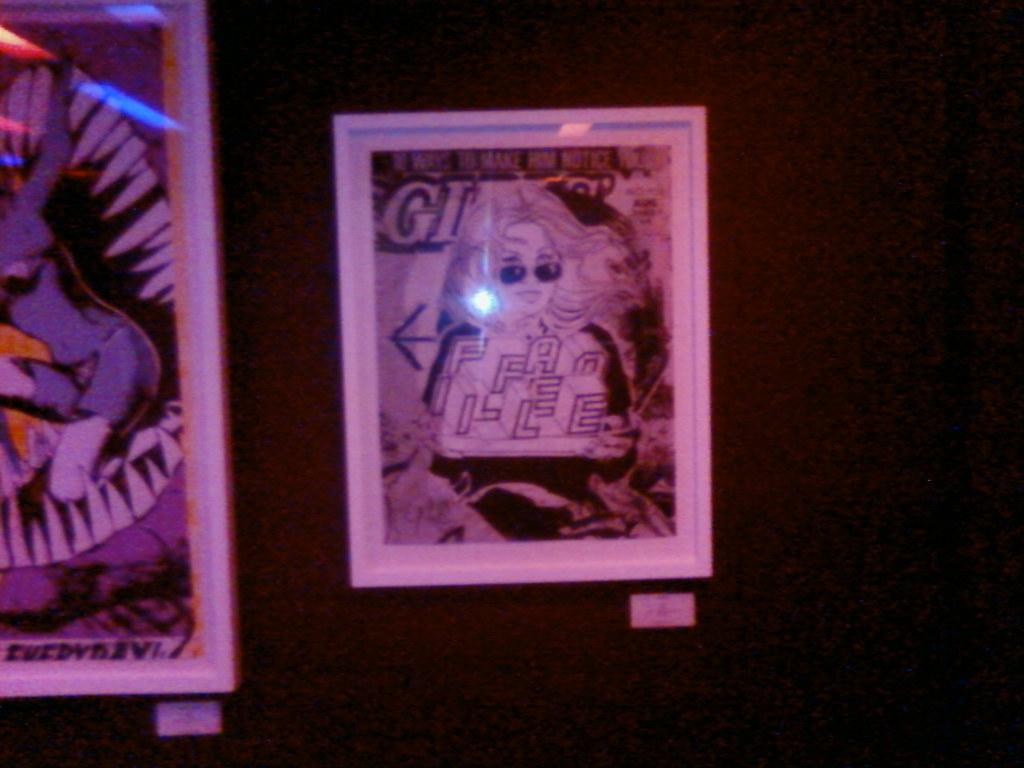<image>
Render a clear and concise summary of the photo. a framed paper that says 'gi' on it 